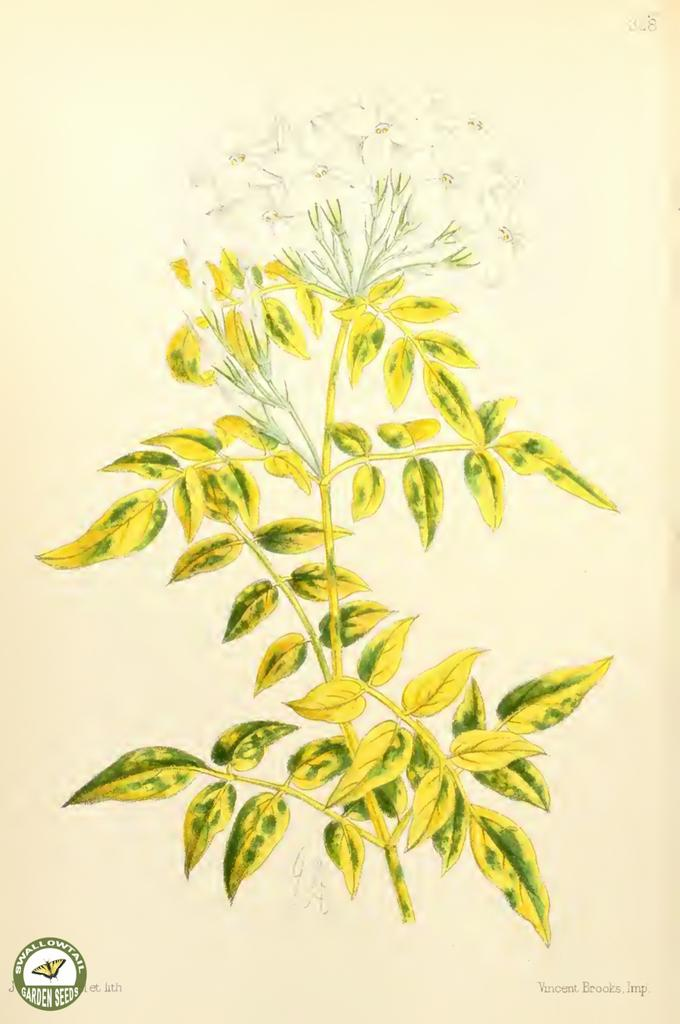What is depicted on the poster in the image? The poster features a plant. Where is the logo located on the poster? The logo is on the left side at the bottom of the poster. What year is the advertisement for the key featured on the poster? There is no advertisement or key present on the poster; it only features a plant and a logo. 